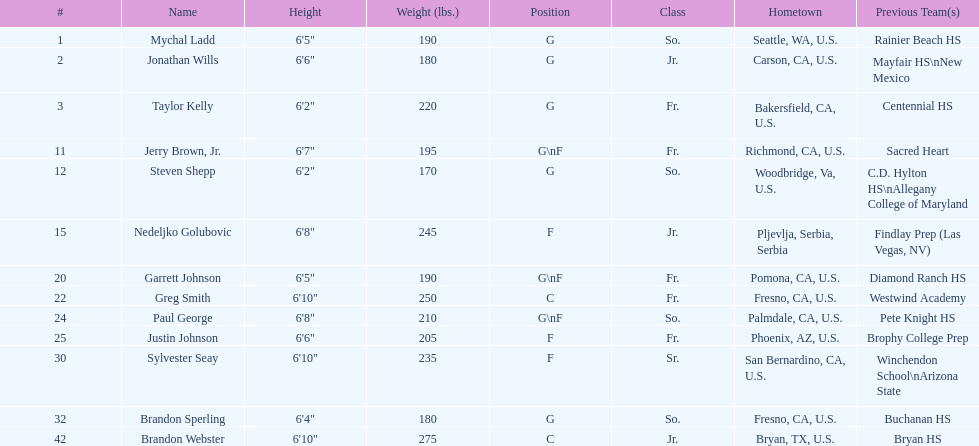Write the full table. {'header': ['#', 'Name', 'Height', 'Weight (lbs.)', 'Position', 'Class', 'Hometown', 'Previous Team(s)'], 'rows': [['1', 'Mychal Ladd', '6\'5"', '190', 'G', 'So.', 'Seattle, WA, U.S.', 'Rainier Beach HS'], ['2', 'Jonathan Wills', '6\'6"', '180', 'G', 'Jr.', 'Carson, CA, U.S.', 'Mayfair HS\\nNew Mexico'], ['3', 'Taylor Kelly', '6\'2"', '220', 'G', 'Fr.', 'Bakersfield, CA, U.S.', 'Centennial HS'], ['11', 'Jerry Brown, Jr.', '6\'7"', '195', 'G\\nF', 'Fr.', 'Richmond, CA, U.S.', 'Sacred Heart'], ['12', 'Steven Shepp', '6\'2"', '170', 'G', 'So.', 'Woodbridge, Va, U.S.', 'C.D. Hylton HS\\nAllegany College of Maryland'], ['15', 'Nedeljko Golubovic', '6\'8"', '245', 'F', 'Jr.', 'Pljevlja, Serbia, Serbia', 'Findlay Prep (Las Vegas, NV)'], ['20', 'Garrett Johnson', '6\'5"', '190', 'G\\nF', 'Fr.', 'Pomona, CA, U.S.', 'Diamond Ranch HS'], ['22', 'Greg Smith', '6\'10"', '250', 'C', 'Fr.', 'Fresno, CA, U.S.', 'Westwind Academy'], ['24', 'Paul George', '6\'8"', '210', 'G\\nF', 'So.', 'Palmdale, CA, U.S.', 'Pete Knight HS'], ['25', 'Justin Johnson', '6\'6"', '205', 'F', 'Fr.', 'Phoenix, AZ, U.S.', 'Brophy College Prep'], ['30', 'Sylvester Seay', '6\'10"', '235', 'F', 'Sr.', 'San Bernardino, CA, U.S.', 'Winchendon School\\nArizona State'], ['32', 'Brandon Sperling', '6\'4"', '180', 'G', 'So.', 'Fresno, CA, U.S.', 'Buchanan HS'], ['42', 'Brandon Webster', '6\'10"', '275', 'C', 'Jr.', 'Bryan, TX, U.S.', 'Bryan HS']]} What is the number of players who weight over 200 pounds? 7. 